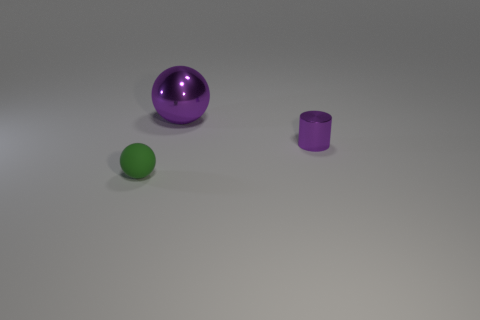Add 2 purple metal spheres. How many objects exist? 5 Subtract all balls. How many objects are left? 1 Add 2 cyan metal things. How many cyan metal things exist? 2 Subtract 0 blue cubes. How many objects are left? 3 Subtract all purple metallic balls. Subtract all red matte things. How many objects are left? 2 Add 3 small purple metallic objects. How many small purple metallic objects are left? 4 